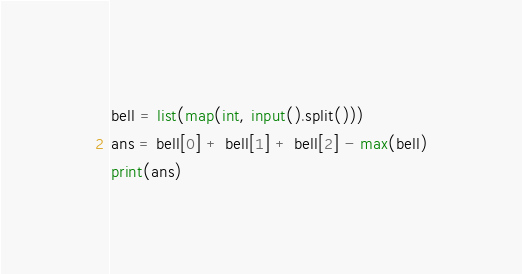Convert code to text. <code><loc_0><loc_0><loc_500><loc_500><_Python_>bell = list(map(int, input().split()))
ans = bell[0] + bell[1] + bell[2] - max(bell)
print(ans)</code> 